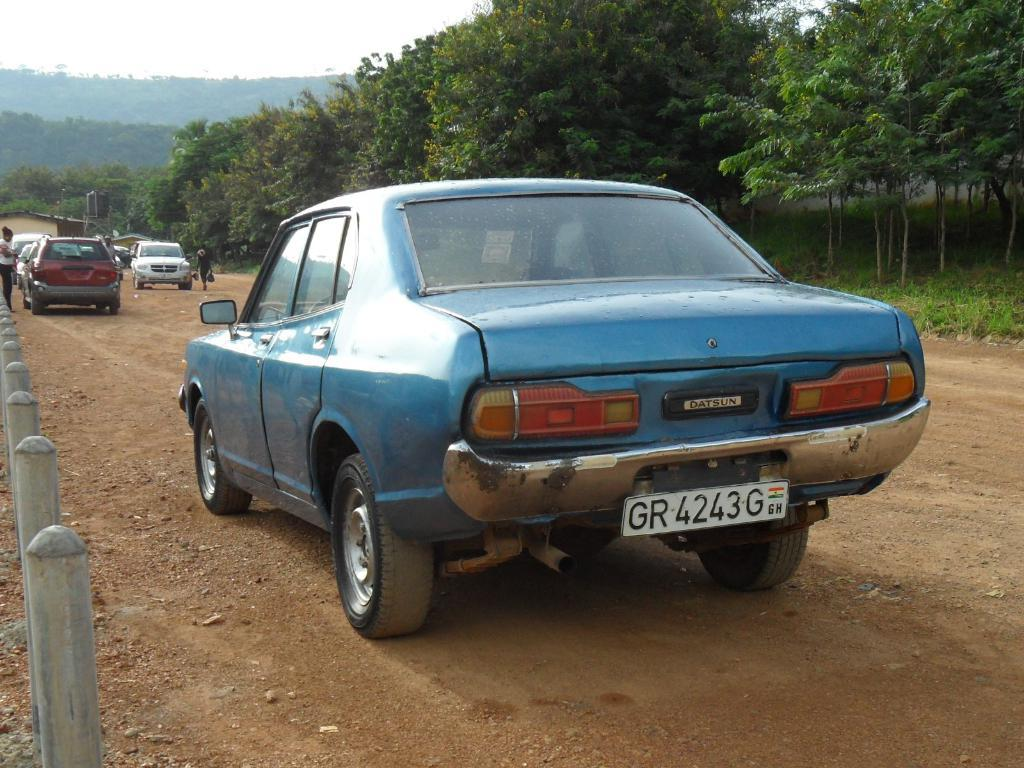What types of objects are present in the image? There are vehicles in the image. How many people can be seen in the image? There are two persons in the image. What type of natural environment is visible in the image? There is grass and trees in the image. What can be seen in the background of the image? The sky is visible in the background of the image. What type of bread is being used for the activity in the image? There is no bread or activity involving bread present in the image. 